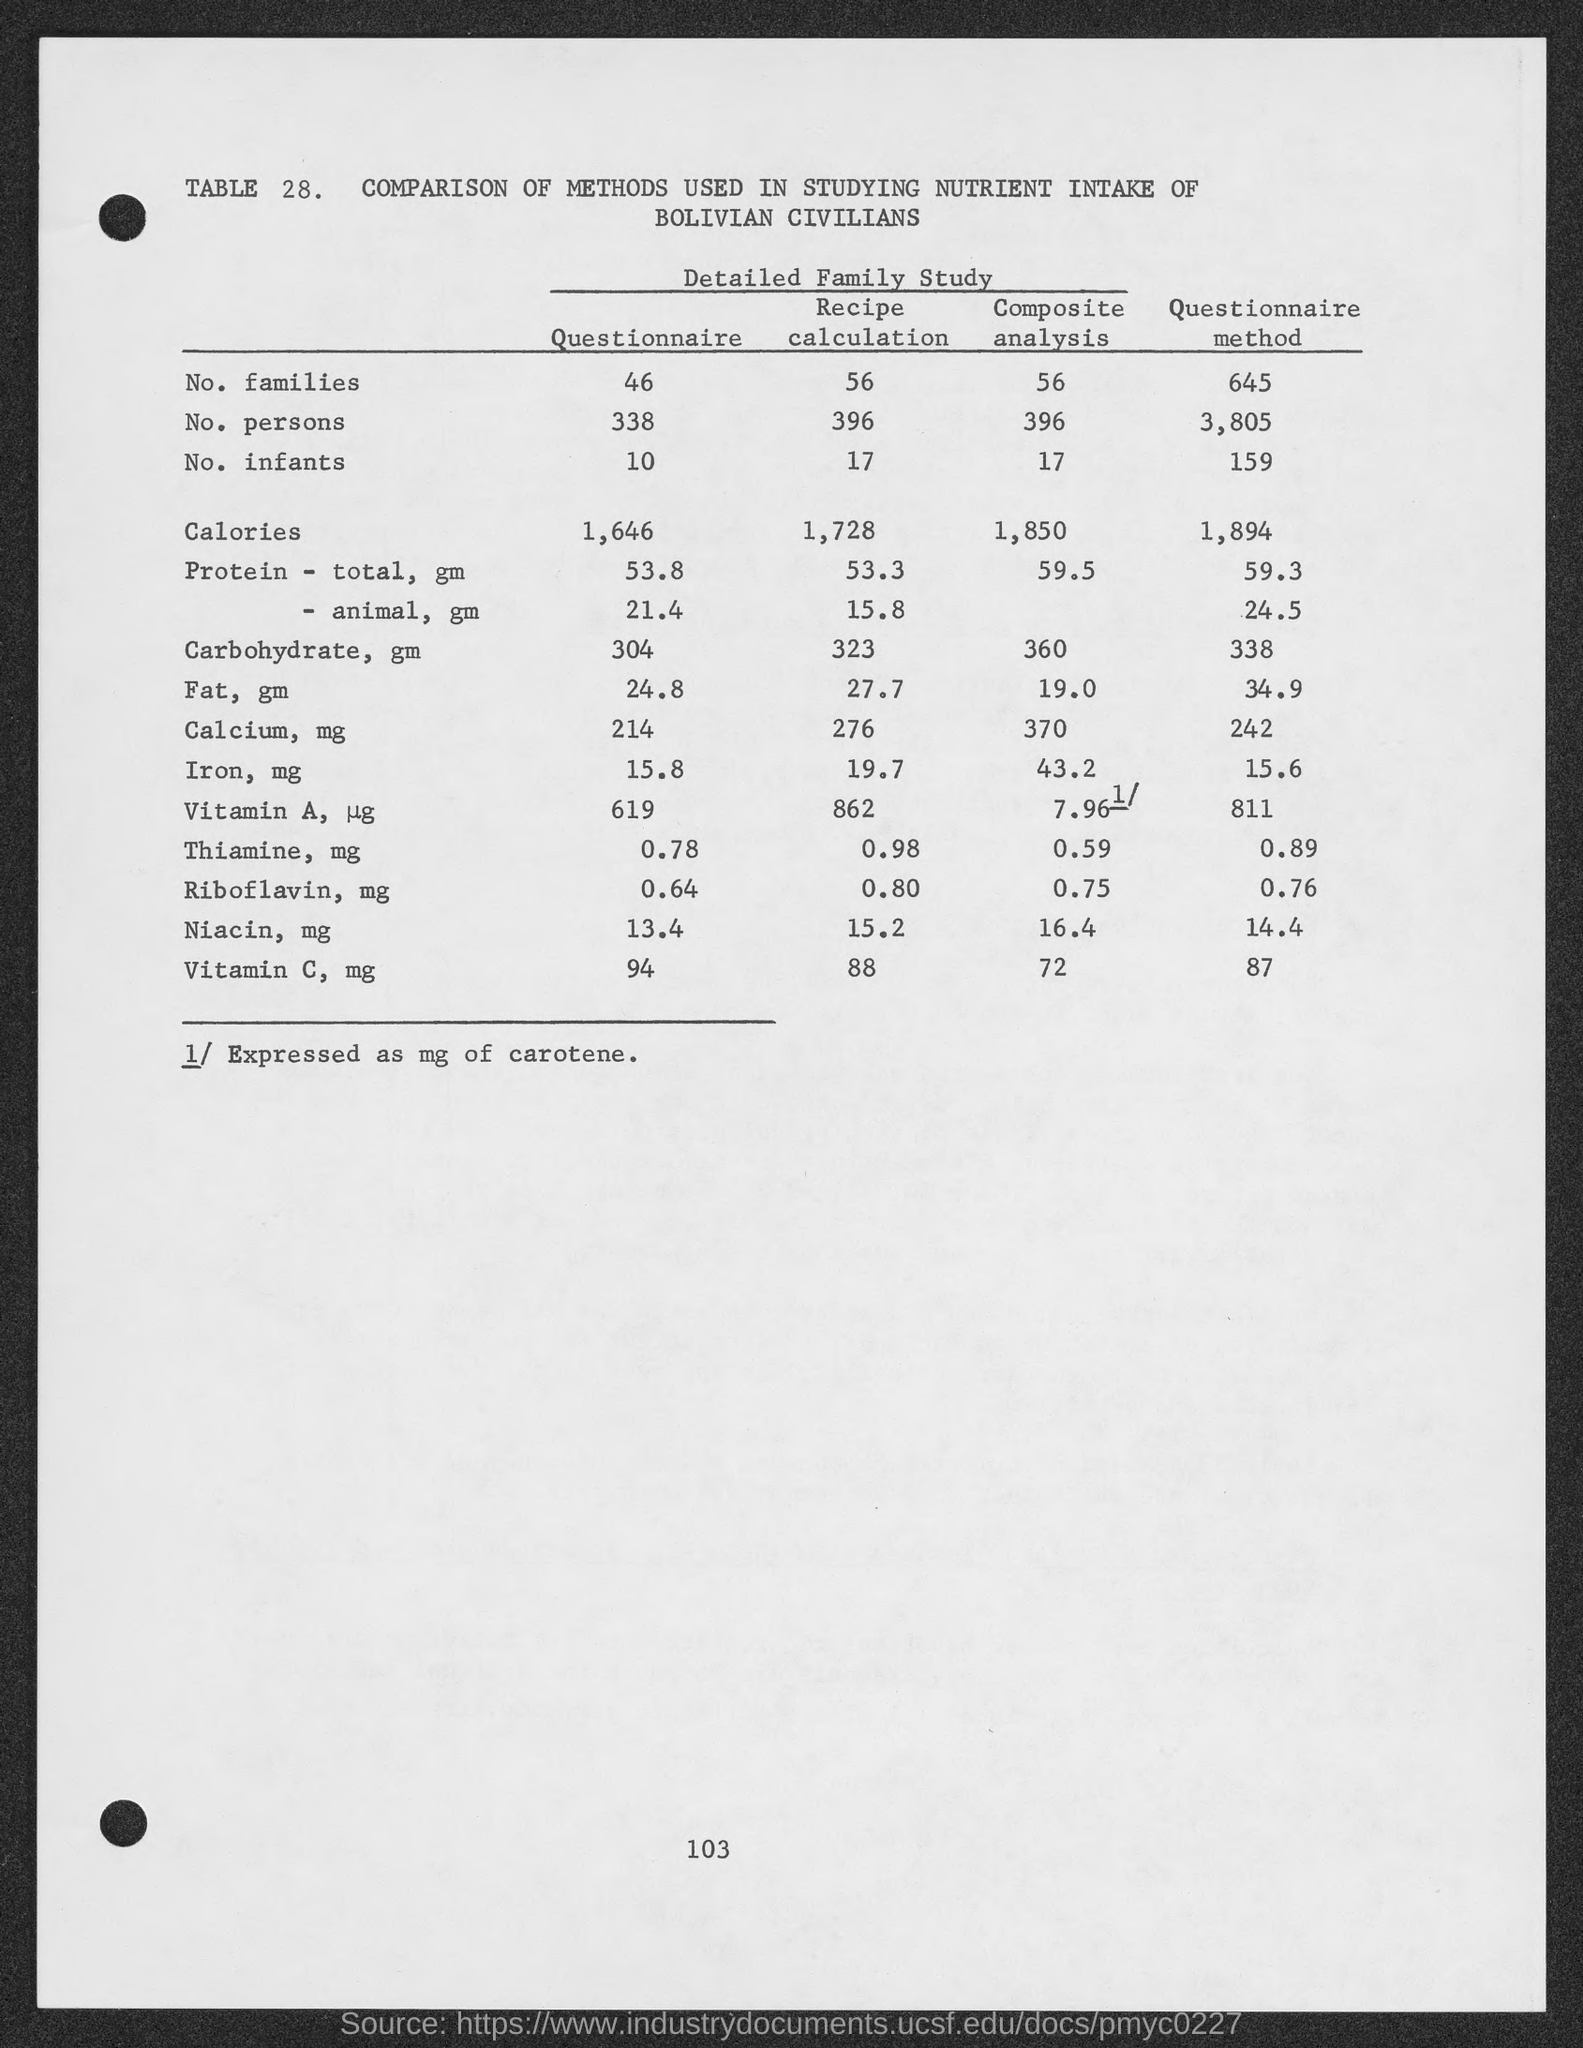Draw attention to some important aspects in this diagram. The number of persons included in the questionnaire is 338. There are 10 infants included in the questionnaire. The page number is 103. There are 46 families in the questionnaire. 